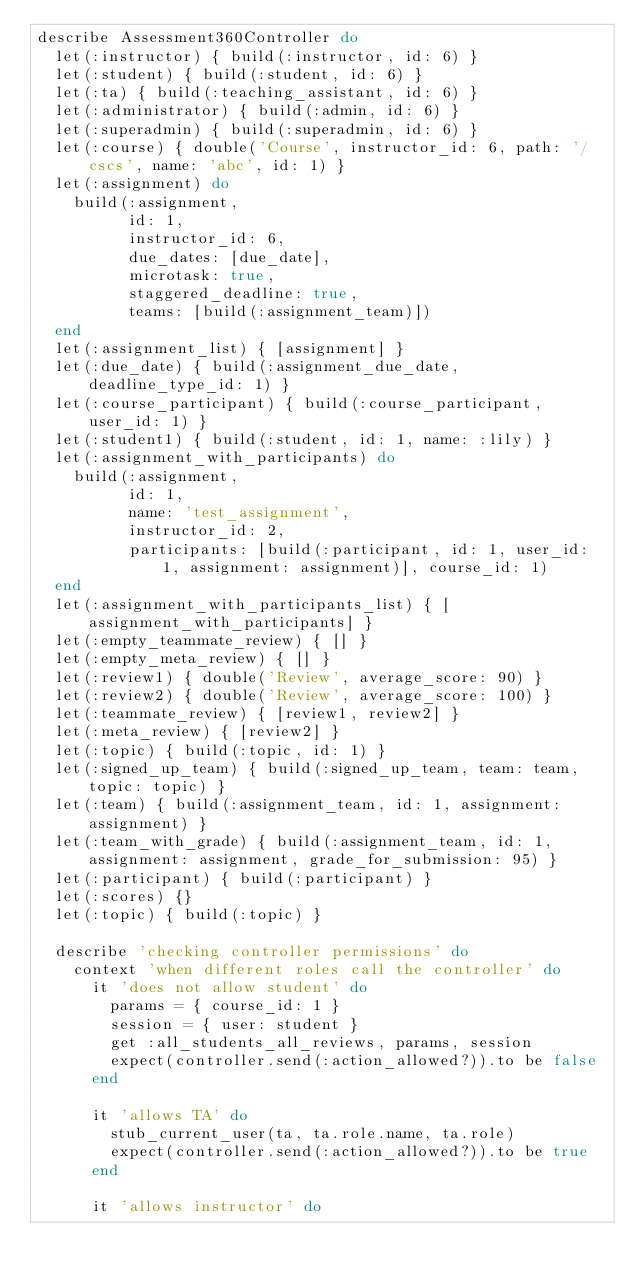<code> <loc_0><loc_0><loc_500><loc_500><_Ruby_>describe Assessment360Controller do
  let(:instructor) { build(:instructor, id: 6) }
  let(:student) { build(:student, id: 6) }
  let(:ta) { build(:teaching_assistant, id: 6) }
  let(:administrator) { build(:admin, id: 6) }
  let(:superadmin) { build(:superadmin, id: 6) }
  let(:course) { double('Course', instructor_id: 6, path: '/cscs', name: 'abc', id: 1) }
  let(:assignment) do
    build(:assignment,
          id: 1,
          instructor_id: 6,
          due_dates: [due_date],
          microtask: true,
          staggered_deadline: true,
          teams: [build(:assignment_team)])
  end
  let(:assignment_list) { [assignment] }
  let(:due_date) { build(:assignment_due_date, deadline_type_id: 1) }
  let(:course_participant) { build(:course_participant, user_id: 1) }
  let(:student1) { build(:student, id: 1, name: :lily) }
  let(:assignment_with_participants) do
    build(:assignment,
          id: 1,
          name: 'test_assignment',
          instructor_id: 2,
          participants: [build(:participant, id: 1, user_id: 1, assignment: assignment)], course_id: 1)
  end
  let(:assignment_with_participants_list) { [assignment_with_participants] }
  let(:empty_teammate_review) { [] }
  let(:empty_meta_review) { [] }
  let(:review1) { double('Review', average_score: 90) }
  let(:review2) { double('Review', average_score: 100) }
  let(:teammate_review) { [review1, review2] }
  let(:meta_review) { [review2] }
  let(:topic) { build(:topic, id: 1) }
  let(:signed_up_team) { build(:signed_up_team, team: team, topic: topic) }
  let(:team) { build(:assignment_team, id: 1, assignment: assignment) }
  let(:team_with_grade) { build(:assignment_team, id: 1, assignment: assignment, grade_for_submission: 95) }
  let(:participant) { build(:participant) }
  let(:scores) {}
  let(:topic) { build(:topic) }

  describe 'checking controller permissions' do
    context 'when different roles call the controller' do
      it 'does not allow student' do
        params = { course_id: 1 }
        session = { user: student }
        get :all_students_all_reviews, params, session
        expect(controller.send(:action_allowed?)).to be false
      end

      it 'allows TA' do
        stub_current_user(ta, ta.role.name, ta.role)
        expect(controller.send(:action_allowed?)).to be true
      end

      it 'allows instructor' do</code> 